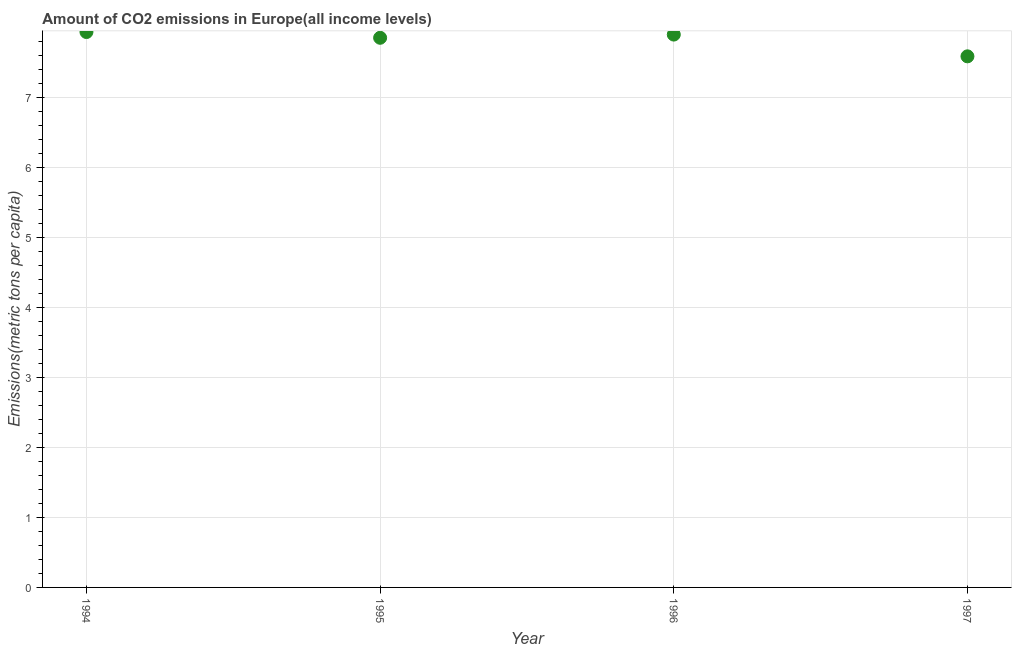What is the amount of co2 emissions in 1997?
Ensure brevity in your answer.  7.59. Across all years, what is the maximum amount of co2 emissions?
Provide a short and direct response. 7.94. Across all years, what is the minimum amount of co2 emissions?
Keep it short and to the point. 7.59. In which year was the amount of co2 emissions maximum?
Offer a very short reply. 1994. What is the sum of the amount of co2 emissions?
Your response must be concise. 31.28. What is the difference between the amount of co2 emissions in 1994 and 1997?
Offer a very short reply. 0.35. What is the average amount of co2 emissions per year?
Your answer should be compact. 7.82. What is the median amount of co2 emissions?
Keep it short and to the point. 7.88. Do a majority of the years between 1997 and 1995 (inclusive) have amount of co2 emissions greater than 5.2 metric tons per capita?
Your response must be concise. No. What is the ratio of the amount of co2 emissions in 1995 to that in 1996?
Give a very brief answer. 0.99. What is the difference between the highest and the second highest amount of co2 emissions?
Provide a succinct answer. 0.04. Is the sum of the amount of co2 emissions in 1995 and 1997 greater than the maximum amount of co2 emissions across all years?
Offer a very short reply. Yes. What is the difference between the highest and the lowest amount of co2 emissions?
Ensure brevity in your answer.  0.35. Does the amount of co2 emissions monotonically increase over the years?
Provide a succinct answer. No. How many dotlines are there?
Offer a very short reply. 1. How many years are there in the graph?
Keep it short and to the point. 4. Does the graph contain grids?
Give a very brief answer. Yes. What is the title of the graph?
Give a very brief answer. Amount of CO2 emissions in Europe(all income levels). What is the label or title of the Y-axis?
Offer a very short reply. Emissions(metric tons per capita). What is the Emissions(metric tons per capita) in 1994?
Provide a short and direct response. 7.94. What is the Emissions(metric tons per capita) in 1995?
Your response must be concise. 7.85. What is the Emissions(metric tons per capita) in 1996?
Your answer should be compact. 7.9. What is the Emissions(metric tons per capita) in 1997?
Keep it short and to the point. 7.59. What is the difference between the Emissions(metric tons per capita) in 1994 and 1995?
Provide a succinct answer. 0.08. What is the difference between the Emissions(metric tons per capita) in 1994 and 1996?
Ensure brevity in your answer.  0.04. What is the difference between the Emissions(metric tons per capita) in 1994 and 1997?
Ensure brevity in your answer.  0.35. What is the difference between the Emissions(metric tons per capita) in 1995 and 1996?
Keep it short and to the point. -0.05. What is the difference between the Emissions(metric tons per capita) in 1995 and 1997?
Your answer should be very brief. 0.27. What is the difference between the Emissions(metric tons per capita) in 1996 and 1997?
Give a very brief answer. 0.31. What is the ratio of the Emissions(metric tons per capita) in 1994 to that in 1996?
Your answer should be very brief. 1. What is the ratio of the Emissions(metric tons per capita) in 1994 to that in 1997?
Keep it short and to the point. 1.05. What is the ratio of the Emissions(metric tons per capita) in 1995 to that in 1996?
Your answer should be very brief. 0.99. What is the ratio of the Emissions(metric tons per capita) in 1995 to that in 1997?
Your response must be concise. 1.03. What is the ratio of the Emissions(metric tons per capita) in 1996 to that in 1997?
Ensure brevity in your answer.  1.04. 